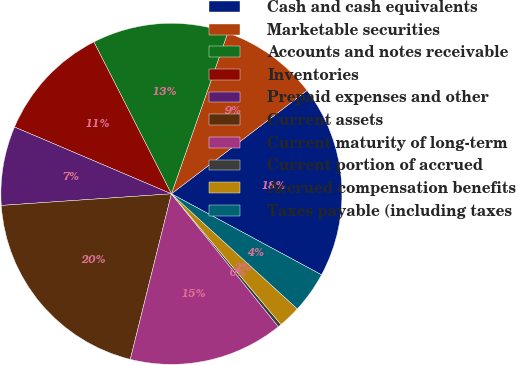Convert chart. <chart><loc_0><loc_0><loc_500><loc_500><pie_chart><fcel>Cash and cash equivalents<fcel>Marketable securities<fcel>Accounts and notes receivable<fcel>Inventories<fcel>Prepaid expenses and other<fcel>Current assets<fcel>Current maturity of long-term<fcel>Current portion of accrued<fcel>Accrued compensation benefits<fcel>Taxes payable (including taxes<nl><fcel>18.24%<fcel>9.28%<fcel>12.87%<fcel>11.08%<fcel>7.49%<fcel>20.04%<fcel>14.66%<fcel>0.32%<fcel>2.11%<fcel>3.91%<nl></chart> 